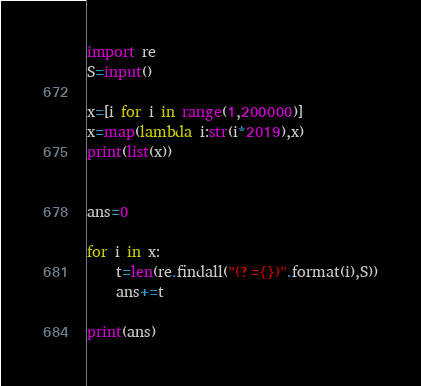Convert code to text. <code><loc_0><loc_0><loc_500><loc_500><_Python_>import re
S=input()

x=[i for i in range(1,200000)]
x=map(lambda i:str(i*2019),x)
print(list(x))


ans=0

for i in x:
    t=len(re.findall("(?={})".format(i),S))
    ans+=t

print(ans)</code> 